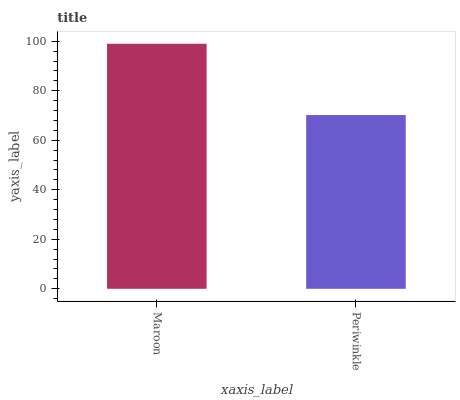Is Periwinkle the minimum?
Answer yes or no. Yes. Is Maroon the maximum?
Answer yes or no. Yes. Is Periwinkle the maximum?
Answer yes or no. No. Is Maroon greater than Periwinkle?
Answer yes or no. Yes. Is Periwinkle less than Maroon?
Answer yes or no. Yes. Is Periwinkle greater than Maroon?
Answer yes or no. No. Is Maroon less than Periwinkle?
Answer yes or no. No. Is Maroon the high median?
Answer yes or no. Yes. Is Periwinkle the low median?
Answer yes or no. Yes. Is Periwinkle the high median?
Answer yes or no. No. Is Maroon the low median?
Answer yes or no. No. 